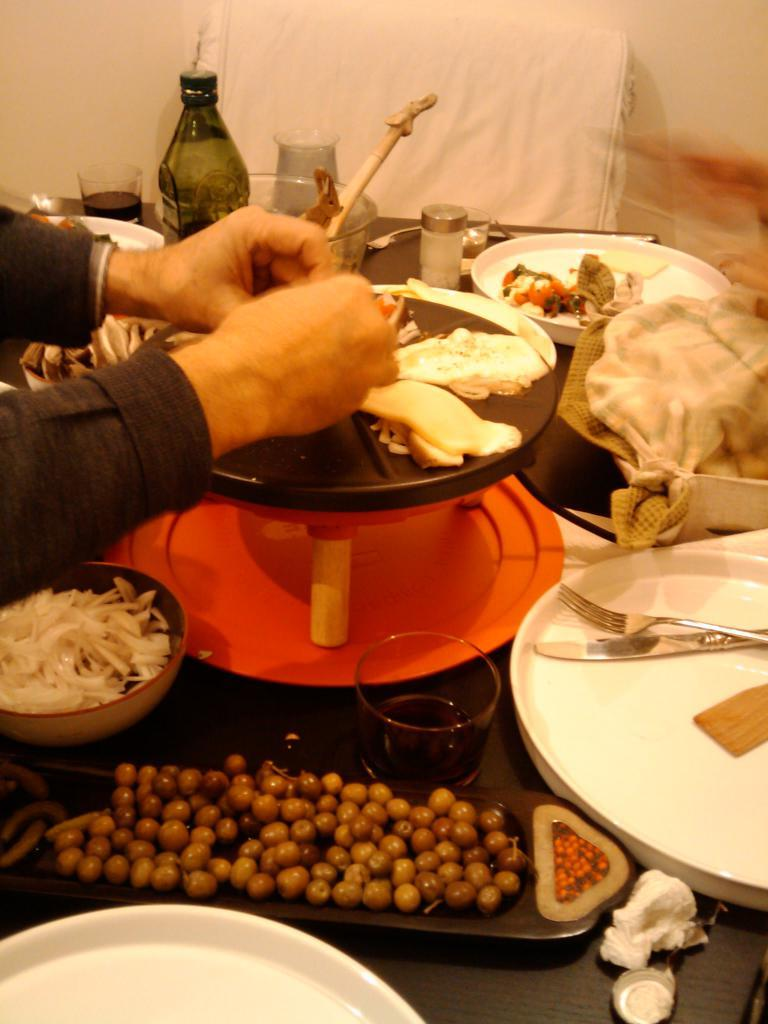What type of objects can be seen in the image? There are food items, spoons, forks, a bottle, and glasses in the image. What utensils are visible in the image? Spoons and forks are visible in the image. What is the container for the liquid in the image? There is a bottle in the image. What type of drinking vessels are present in the image? Glasses are in the image. Where are all of these items located? All of these items are on a table. How many kittens are sitting on the table in the image? There are no kittens present in the image; it only features food items, utensils, a bottle, glasses, and a table. 